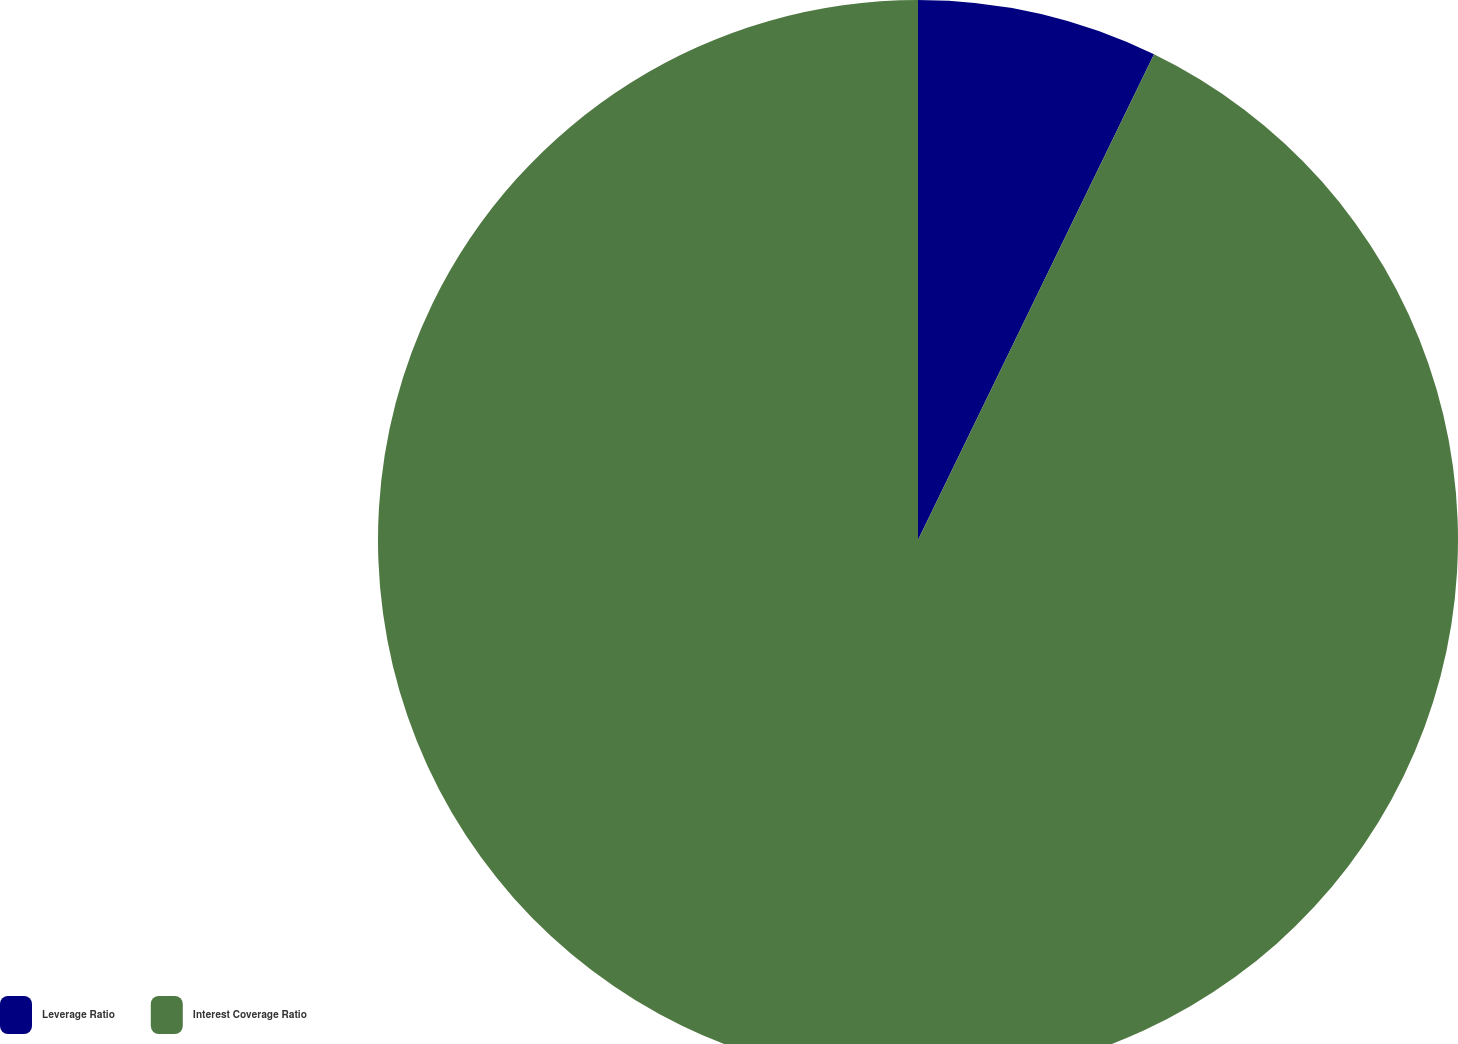Convert chart to OTSL. <chart><loc_0><loc_0><loc_500><loc_500><pie_chart><fcel>Leverage Ratio<fcel>Interest Coverage Ratio<nl><fcel>7.2%<fcel>92.8%<nl></chart> 